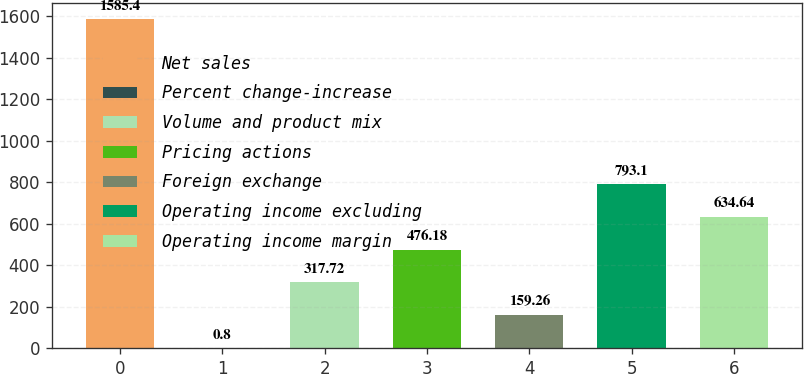Convert chart to OTSL. <chart><loc_0><loc_0><loc_500><loc_500><bar_chart><fcel>Net sales<fcel>Percent change-increase<fcel>Volume and product mix<fcel>Pricing actions<fcel>Foreign exchange<fcel>Operating income excluding<fcel>Operating income margin<nl><fcel>1585.4<fcel>0.8<fcel>317.72<fcel>476.18<fcel>159.26<fcel>793.1<fcel>634.64<nl></chart> 